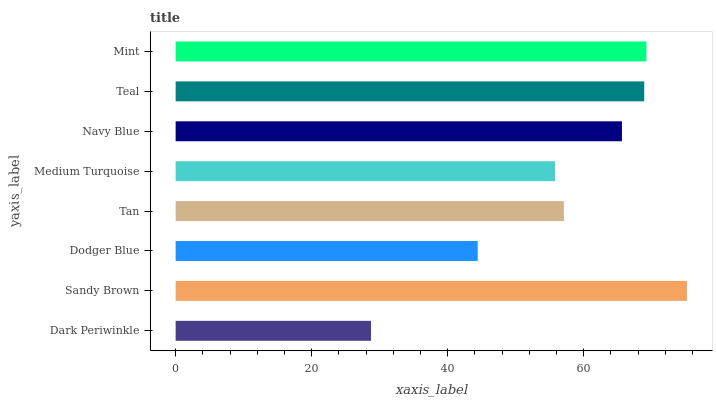Is Dark Periwinkle the minimum?
Answer yes or no. Yes. Is Sandy Brown the maximum?
Answer yes or no. Yes. Is Dodger Blue the minimum?
Answer yes or no. No. Is Dodger Blue the maximum?
Answer yes or no. No. Is Sandy Brown greater than Dodger Blue?
Answer yes or no. Yes. Is Dodger Blue less than Sandy Brown?
Answer yes or no. Yes. Is Dodger Blue greater than Sandy Brown?
Answer yes or no. No. Is Sandy Brown less than Dodger Blue?
Answer yes or no. No. Is Navy Blue the high median?
Answer yes or no. Yes. Is Tan the low median?
Answer yes or no. Yes. Is Teal the high median?
Answer yes or no. No. Is Mint the low median?
Answer yes or no. No. 